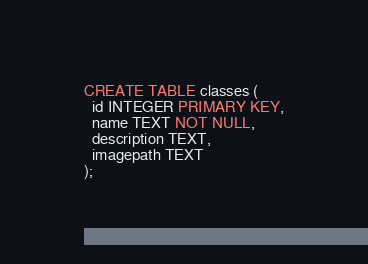Convert code to text. <code><loc_0><loc_0><loc_500><loc_500><_SQL_>CREATE TABLE classes (
  id INTEGER PRIMARY KEY,
  name TEXT NOT NULL,
  description TEXT,
  imagepath TEXT
);
</code> 